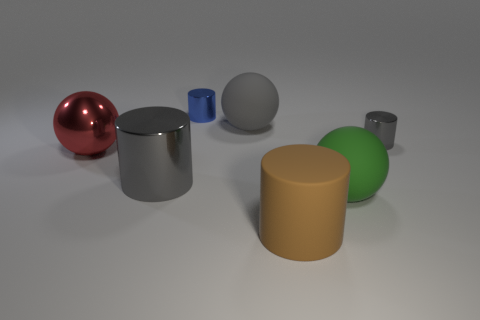Subtract all brown rubber cylinders. How many cylinders are left? 3 Subtract all gray cylinders. How many cylinders are left? 2 Subtract all yellow balls. How many gray cylinders are left? 2 Subtract 2 balls. How many balls are left? 1 Add 3 red things. How many objects exist? 10 Subtract all cylinders. How many objects are left? 3 Subtract all gray cylinders. Subtract all cyan spheres. How many cylinders are left? 2 Add 1 large gray matte balls. How many large gray matte balls are left? 2 Add 1 big yellow matte cubes. How many big yellow matte cubes exist? 1 Subtract 1 green spheres. How many objects are left? 6 